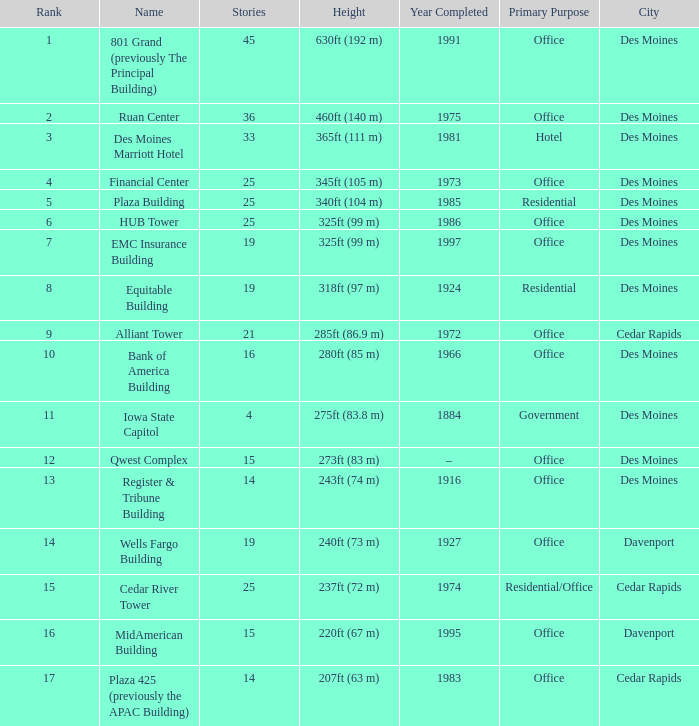What is the total stories that rank number 10? 1.0. 